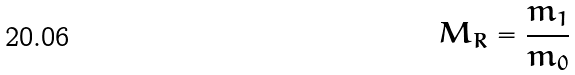<formula> <loc_0><loc_0><loc_500><loc_500>M _ { R } = \frac { m _ { 1 } } { m _ { 0 } }</formula> 